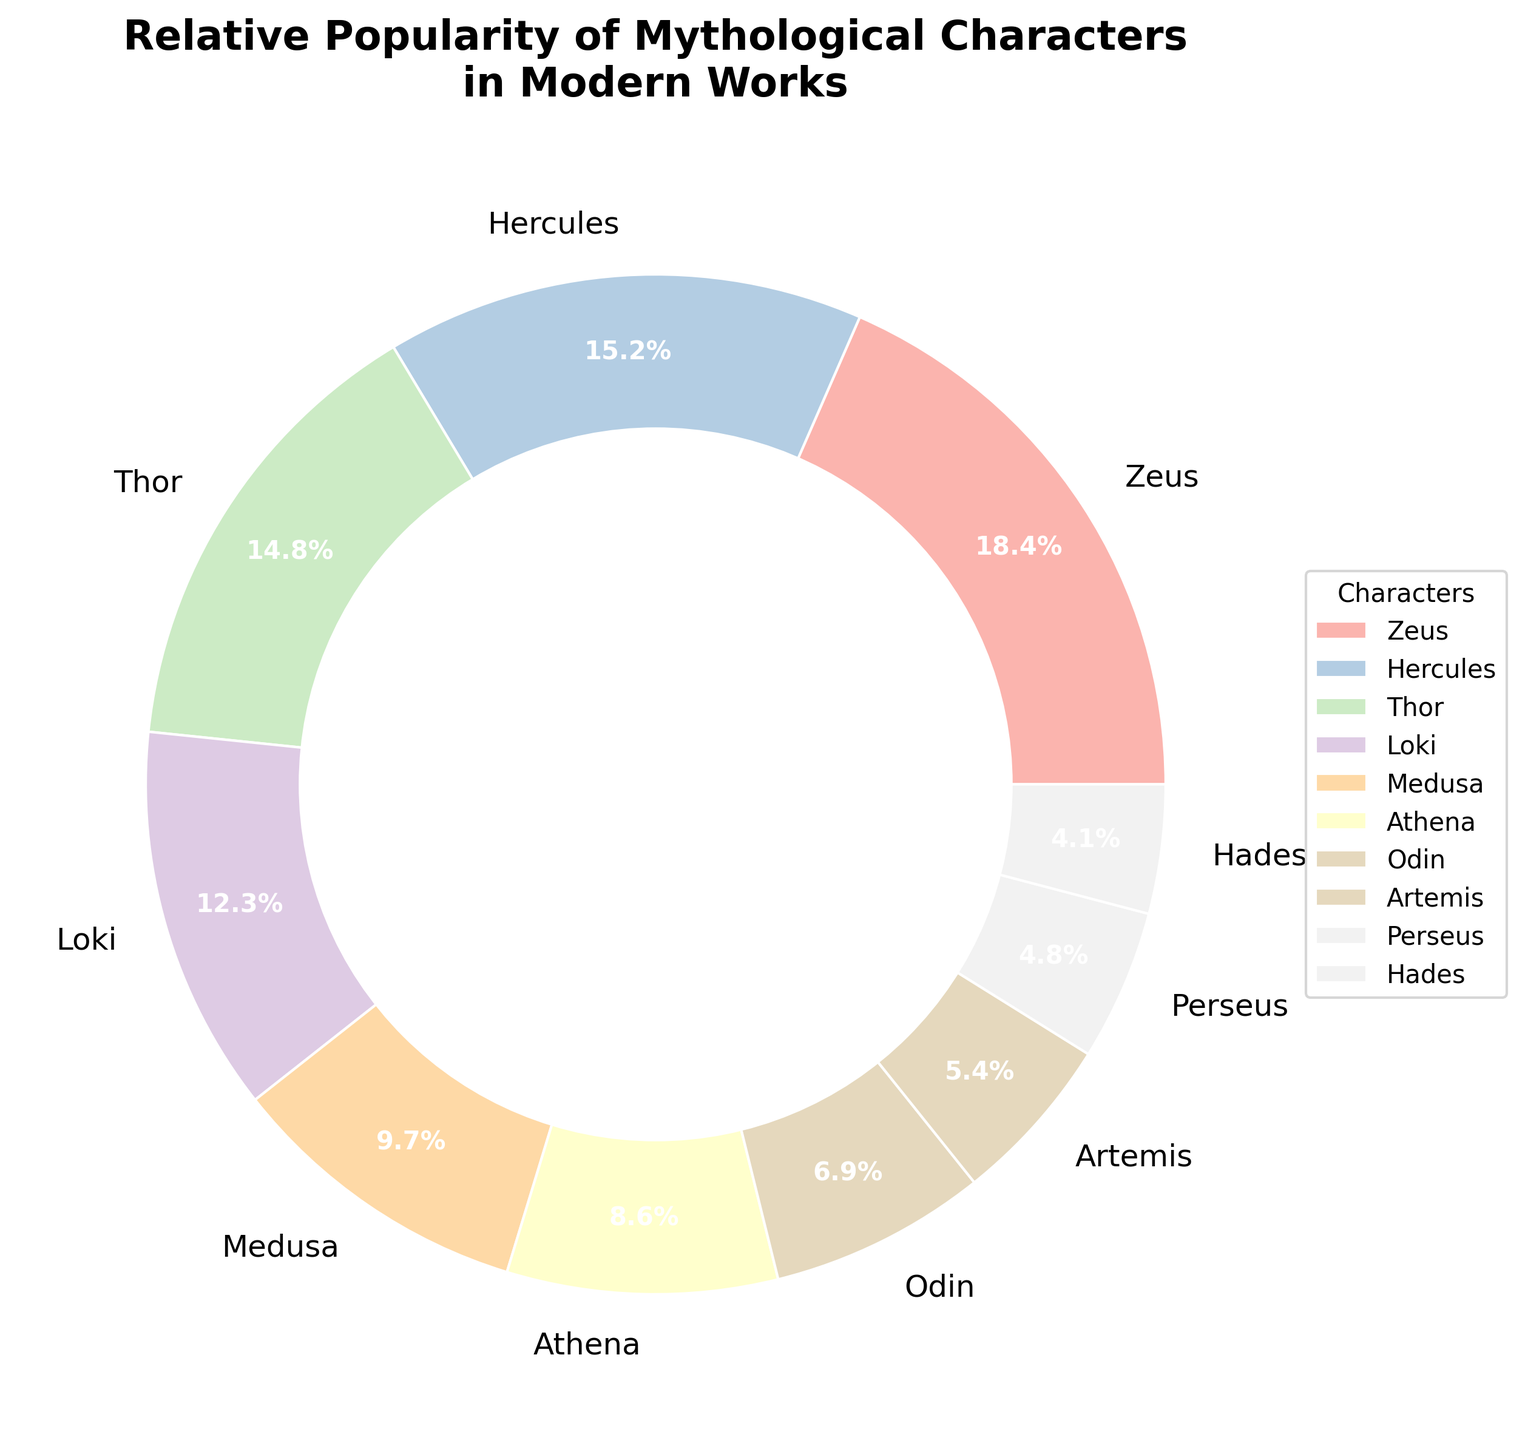Which character has the highest percentage in the chart? Identify the character with the largest pie slice. Zeus has the highest percentage with 18.5%.
Answer: Zeus Which character is more popular, Loki or Medusa? Compare the percentages of the two characters. Loki has 12.3% while Medusa has 9.7%, indicating Loki is more popular.
Answer: Loki What is the total percentage for Zeus, Hercules, and Thor combined? Add the percentages of the three characters: 18.5% + 15.2% + 14.8% = 48.5%.
Answer: 48.5% How much more popular is Zeus compared to Hades? Subtract Hades' percentage from Zeus' percentage: 18.5% - 4.1% = 14.4%.
Answer: 14.4% Are there more characters with percentages above 10% or below 10%? Count the characters in each category: Above 10%: Zeus, Hercules, Thor, Loki (4 characters); Below 10%: Medusa, Athena, Odin, Artemis, Perseus, Hades (6 characters). There are more characters below 10%.
Answer: Below 10% What is the average percentage of all characters? First sum all the percentages: 18.5 + 15.2 + 14.8 + 12.3 + 9.7 + 8.6 + 6.9 + 5.4 + 4.8 + 4.1 = 100.3. Since there are 10 characters, the average is 100.3/10 = 10.03%.
Answer: 10.03% Which character has a smaller percentage visually represented by a lighter pastel color compared to Artemis? Visually scan the colors; Hades and Perseus have segments in lighter colors and both have smaller percentages compared to Artemis.
Answer: Perseus or Hades How does the percentage of Athena compare to that of Odin and Artemis combined? First find the combined percentage of Odin and Artemis: 6.9% + 5.4% = 12.3%. Athena's percentage is 8.6%, which is less than 12.3%.
Answer: Less If you combine the percentages of the three least popular characters, what is their total percentage? Find the three characters with the smallest percentages: Hades (4.1%), Perseus (4.8%), and Artemis (5.4%). Add these together: 4.1% + 4.8% + 5.4% = 14.3%.
Answer: 14.3% Which character's percentage is the closest to the average percentage calculated? Average is 10.03%. The closest percentages are Medusa (9.7%) and Athena (8.6%). Medusa is slightly closer to 10.03%.
Answer: Medusa 